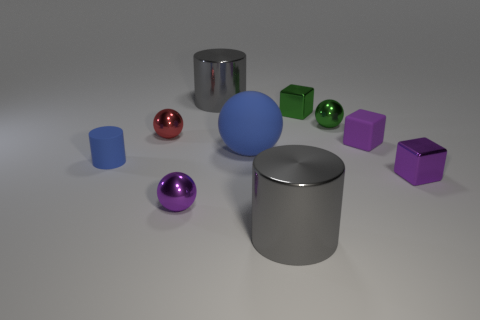The other thing that is the same color as the big matte thing is what shape?
Your answer should be very brief. Cylinder. Is the red ball made of the same material as the purple ball?
Ensure brevity in your answer.  Yes. What number of large gray cylinders are on the right side of the large blue rubber ball?
Your answer should be compact. 1. What is the material of the small ball that is behind the tiny purple rubber thing and left of the green metal block?
Your answer should be compact. Metal. What number of blocks are purple things or small green things?
Your response must be concise. 3. What is the material of the purple object that is the same shape as the red shiny object?
Your response must be concise. Metal. There is a green cube that is the same material as the tiny red ball; what size is it?
Provide a short and direct response. Small. There is a large gray thing that is in front of the purple metal sphere; is its shape the same as the large metallic thing that is behind the blue cylinder?
Your answer should be compact. Yes. There is a block that is the same material as the large blue sphere; what color is it?
Keep it short and to the point. Purple. Do the gray cylinder that is in front of the blue matte ball and the shiny cube that is in front of the small green shiny ball have the same size?
Keep it short and to the point. No. 